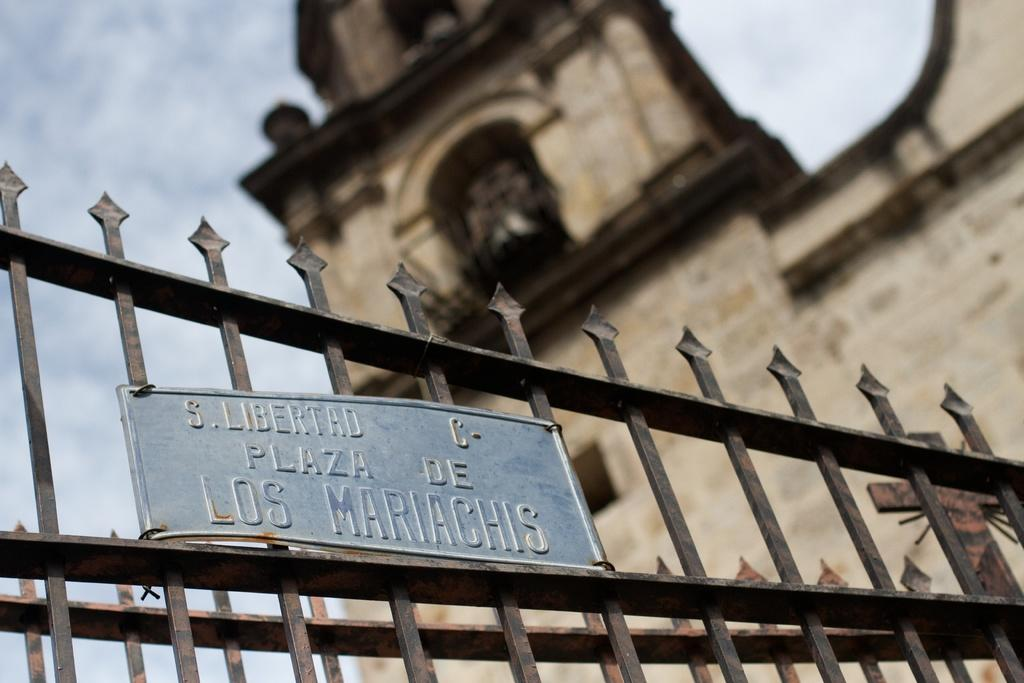What type of structure is visible in the image? There is a building in the image. Can you describe any additional features or objects in the image? There is a board with text on a metal fence in the image. What type of guitar can be seen being played by the representative in the harbor in the image? There is no guitar, representative, or harbor present in the image. 